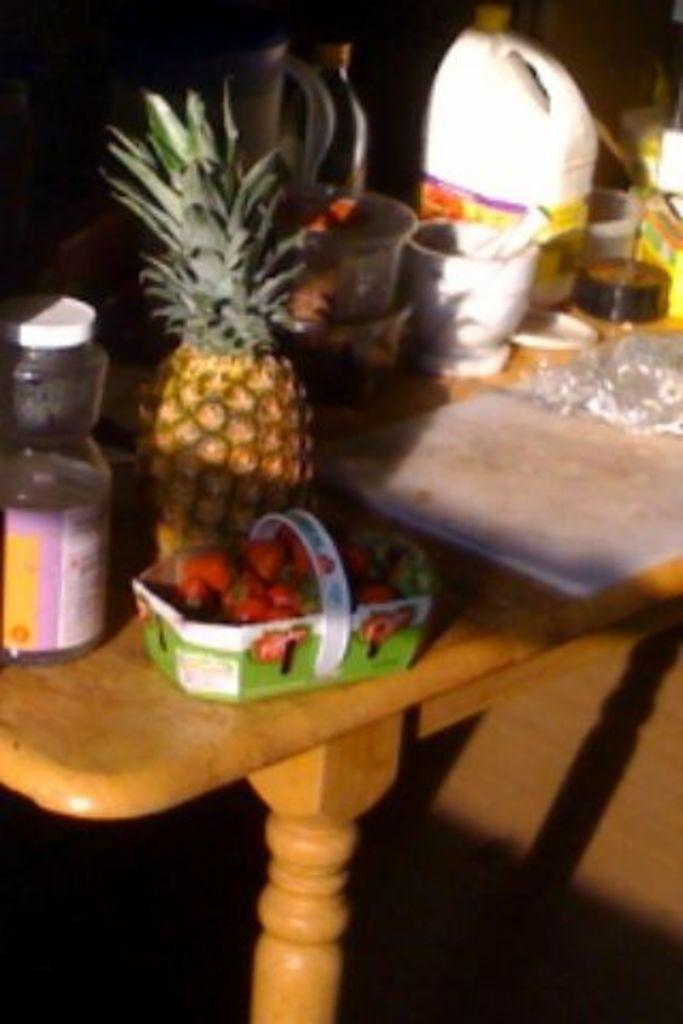What is on the table in the image? There is a jar, a pineapple, strawberries in a basket, a bottle, and a can on the table in the image. Can you describe the strawberries in the image? The strawberries are in a basket on the table in the image. What other objects are on the table in the image? There are additional objects on the table in the image, but their specific details are not mentioned in the provided facts. How many goldfish are swimming in the jar in the image? There are no goldfish present in the image; the jar is empty or contains other items. 